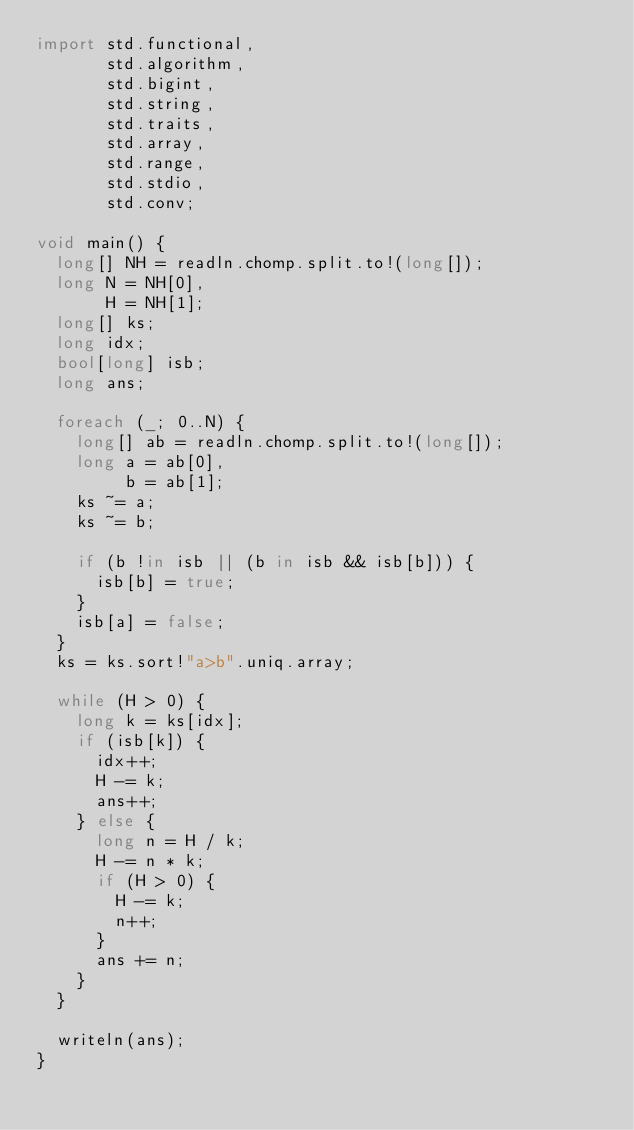<code> <loc_0><loc_0><loc_500><loc_500><_D_>import std.functional,
       std.algorithm,
       std.bigint,
       std.string,
       std.traits,
       std.array,
       std.range,
       std.stdio,
       std.conv;

void main() {
  long[] NH = readln.chomp.split.to!(long[]);
  long N = NH[0],
       H = NH[1];
  long[] ks;
  long idx;
  bool[long] isb;
  long ans;

  foreach (_; 0..N) {
    long[] ab = readln.chomp.split.to!(long[]);
    long a = ab[0],
         b = ab[1];
    ks ~= a;
    ks ~= b;

    if (b !in isb || (b in isb && isb[b])) {
      isb[b] = true;
    }
    isb[a] = false;
  }
  ks = ks.sort!"a>b".uniq.array;

  while (H > 0) {
    long k = ks[idx];
    if (isb[k]) {
      idx++;
      H -= k;
      ans++;
    } else {
      long n = H / k;
      H -= n * k;
      if (H > 0) {
        H -= k;
        n++;
      }
      ans += n;
    }
  }

  writeln(ans);
}
</code> 